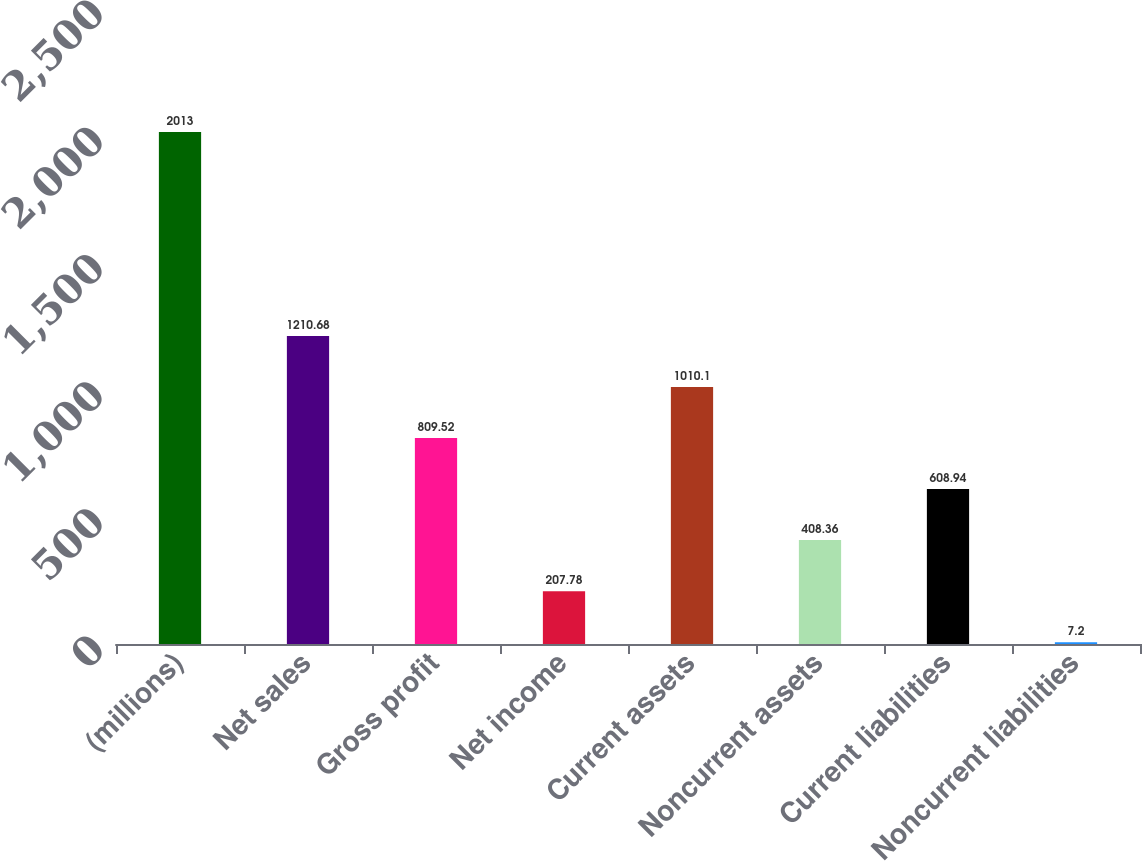<chart> <loc_0><loc_0><loc_500><loc_500><bar_chart><fcel>(millions)<fcel>Net sales<fcel>Gross profit<fcel>Net income<fcel>Current assets<fcel>Noncurrent assets<fcel>Current liabilities<fcel>Noncurrent liabilities<nl><fcel>2013<fcel>1210.68<fcel>809.52<fcel>207.78<fcel>1010.1<fcel>408.36<fcel>608.94<fcel>7.2<nl></chart> 